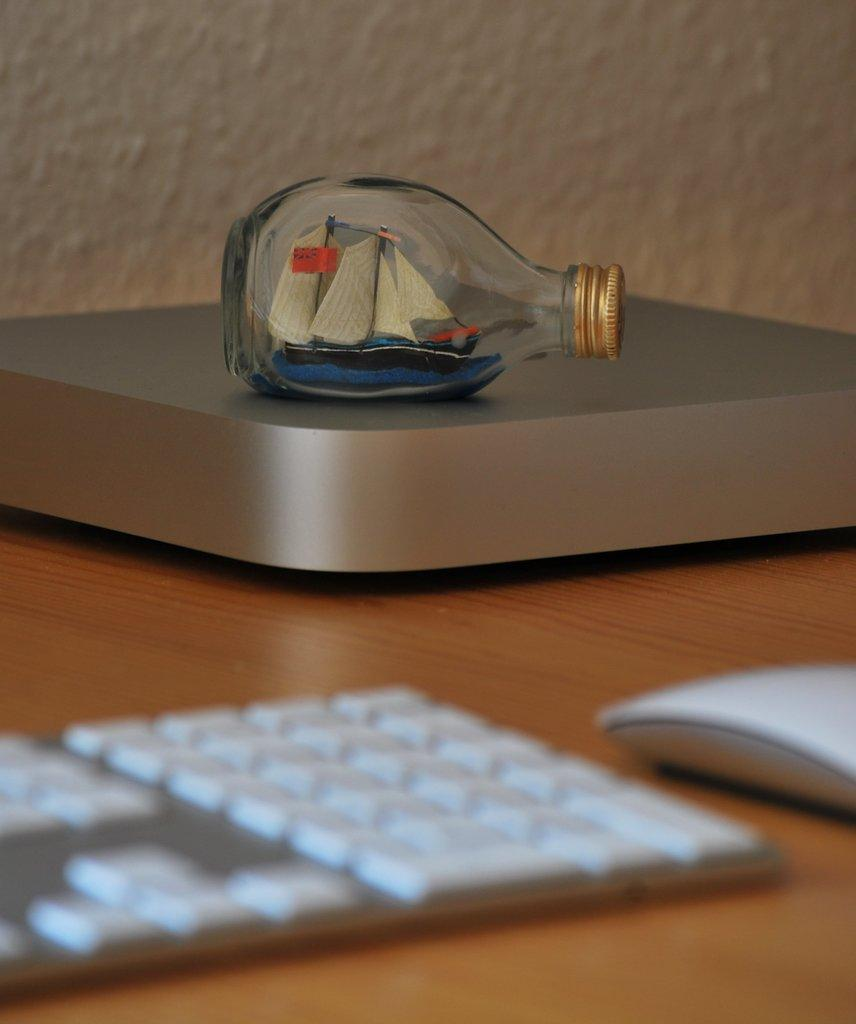What object can be seen in the image that is typically used for holding liquids? There is a bottle in the image that is typically used for holding liquids. What object can be seen in the image that is typically used for typing? There is a keyboard in the image that is typically used for typing. Where are the bottle and keyboard located in the image? Both the bottle and the keyboard are on a table in the image. What can be seen in the background of the image? There is a wall in the background of the image. What news is being reported on the earth in the image? There is no news or earth present in the image; it only features a bottle, a keyboard, and a wall in the background. 